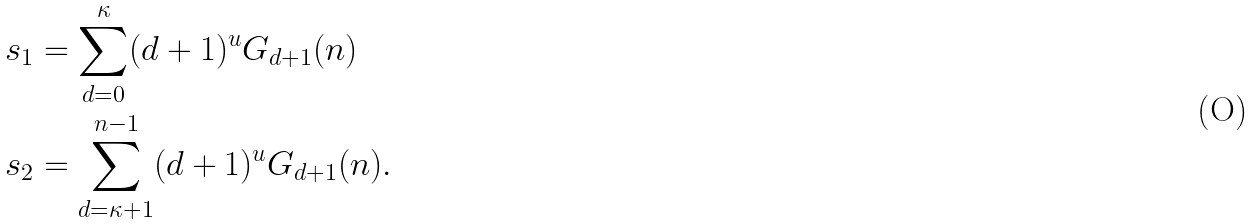Convert formula to latex. <formula><loc_0><loc_0><loc_500><loc_500>s _ { 1 } & = \sum _ { d = 0 } ^ { \kappa } ( d + 1 ) ^ { u } G _ { d + 1 } ( n ) \\ s _ { 2 } & = \sum _ { d = \kappa + 1 } ^ { n - 1 } ( d + 1 ) ^ { u } G _ { d + 1 } ( n ) .</formula> 